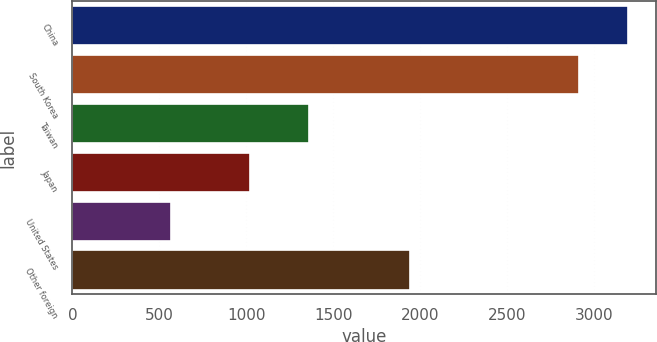Convert chart. <chart><loc_0><loc_0><loc_500><loc_500><bar_chart><fcel>China<fcel>South Korea<fcel>Taiwan<fcel>Japan<fcel>United States<fcel>Other foreign<nl><fcel>3194<fcel>2913<fcel>1360<fcel>1018<fcel>564<fcel>1942<nl></chart> 